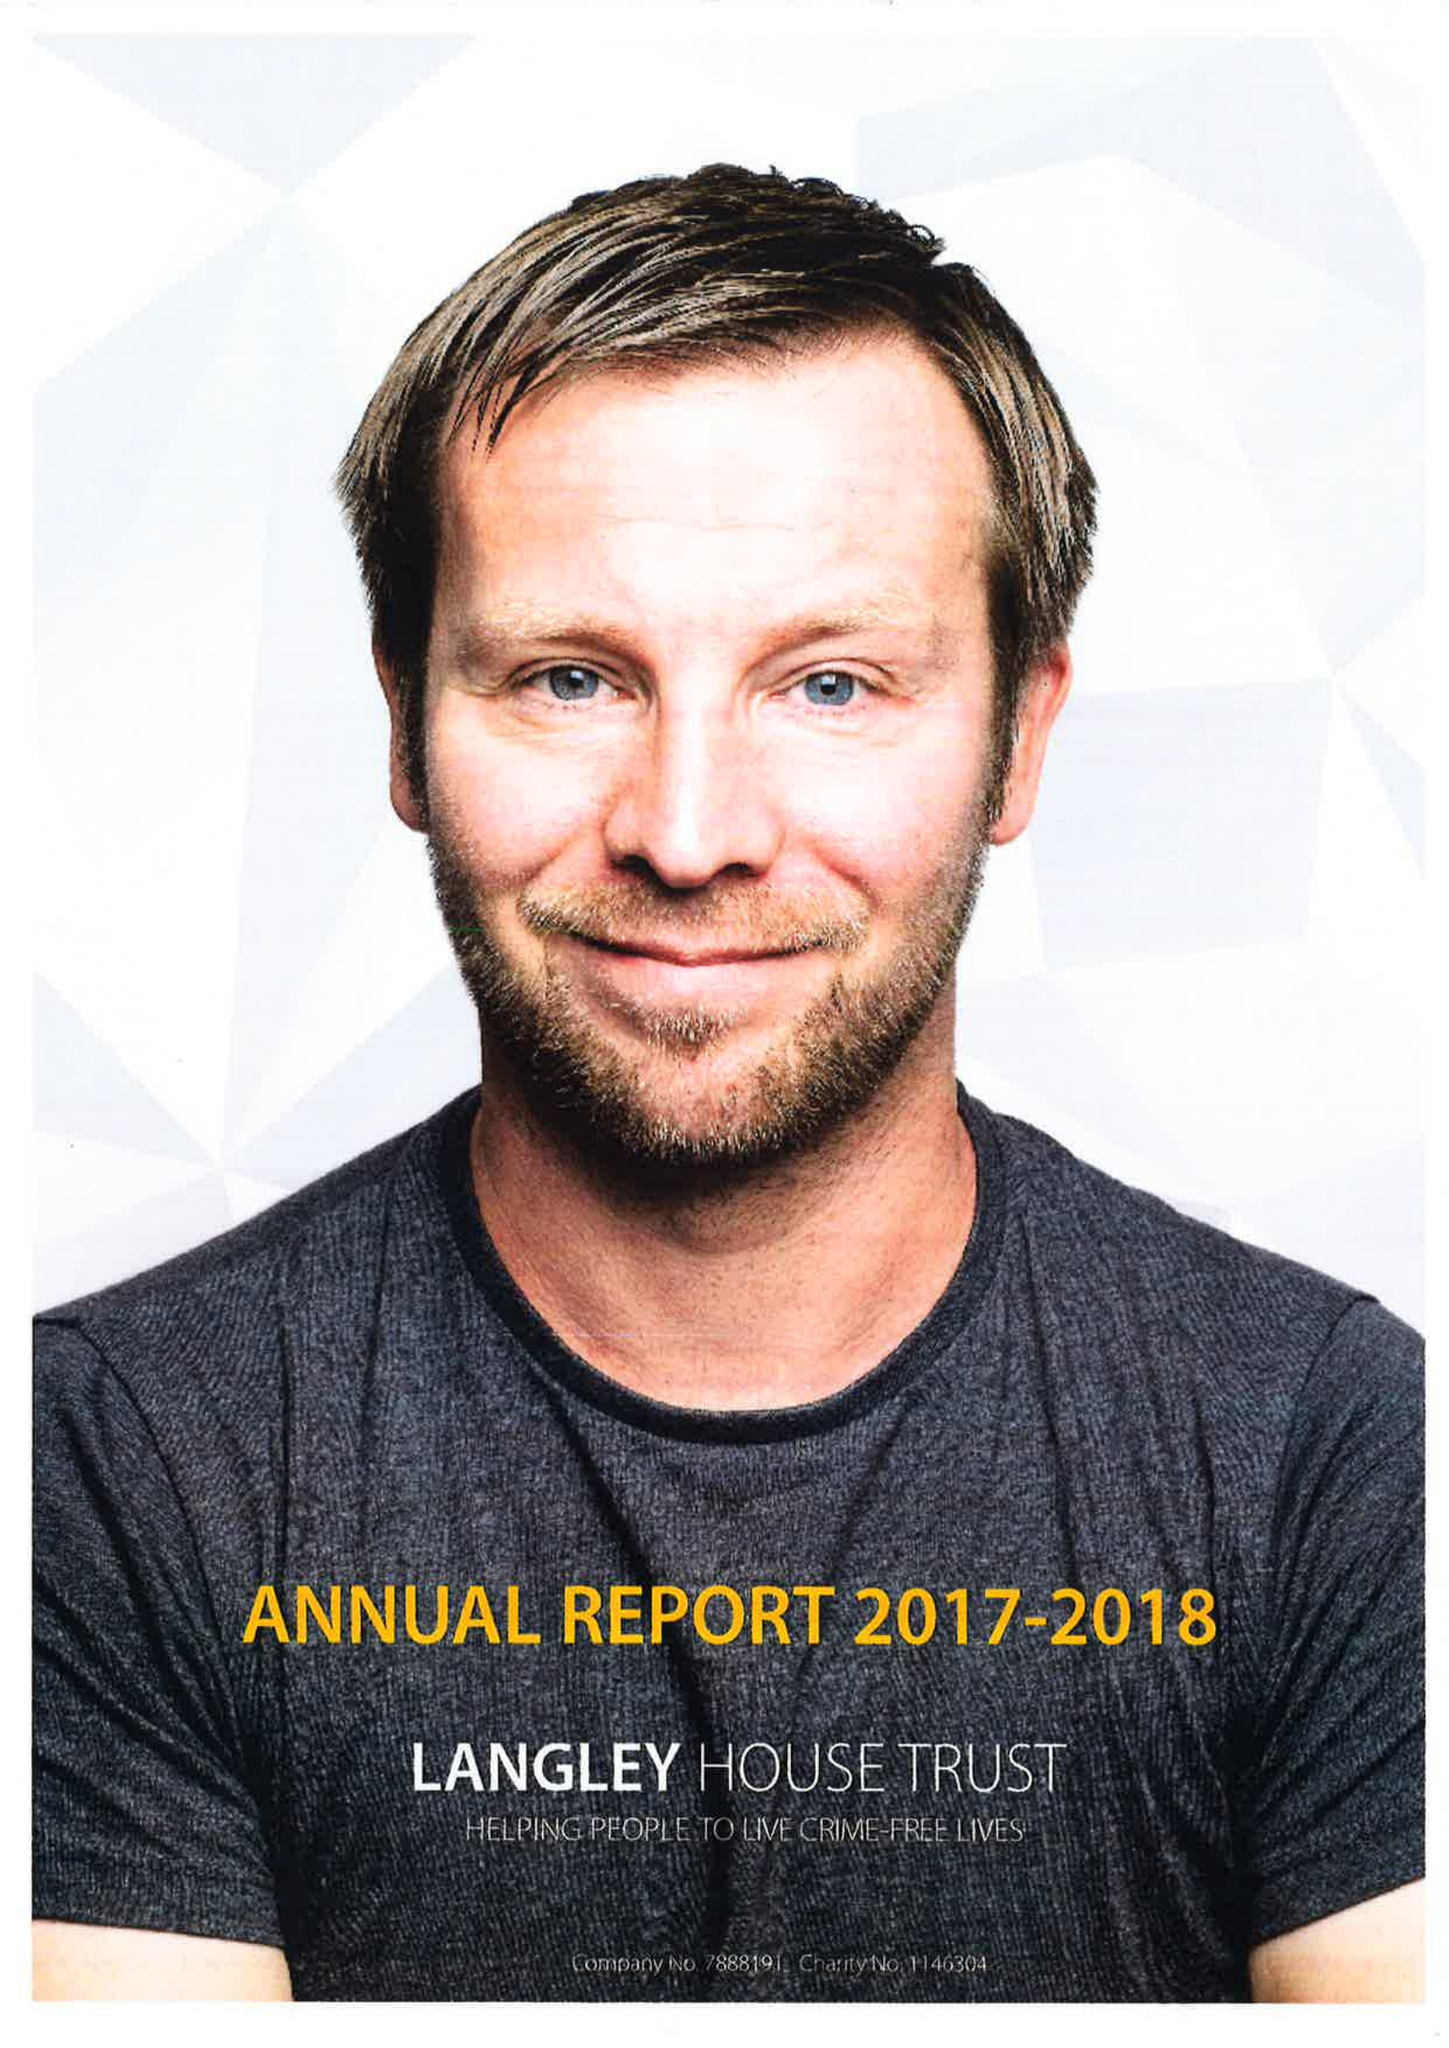What is the value for the address__post_town?
Answer the question using a single word or phrase. COVENTRY 